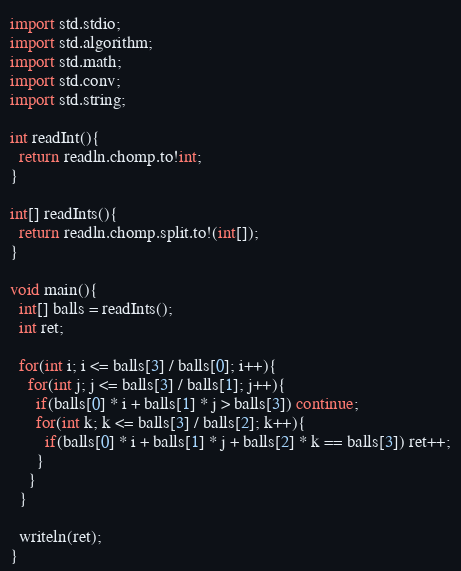<code> <loc_0><loc_0><loc_500><loc_500><_D_>import std.stdio;
import std.algorithm;
import std.math;
import std.conv;
import std.string;

int readInt(){
  return readln.chomp.to!int;
}

int[] readInts(){
  return readln.chomp.split.to!(int[]);
}

void main(){
  int[] balls = readInts();
  int ret;

  for(int i; i <= balls[3] / balls[0]; i++){
    for(int j; j <= balls[3] / balls[1]; j++){
      if(balls[0] * i + balls[1] * j > balls[3]) continue;
      for(int k; k <= balls[3] / balls[2]; k++){
        if(balls[0] * i + balls[1] * j + balls[2] * k == balls[3]) ret++;
      }
    }
  }

  writeln(ret);
}</code> 